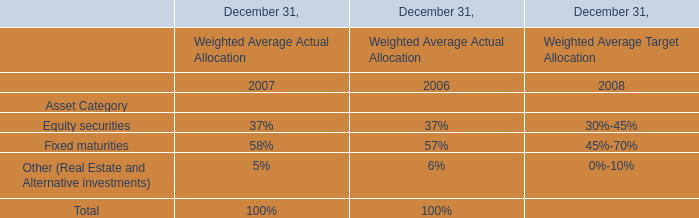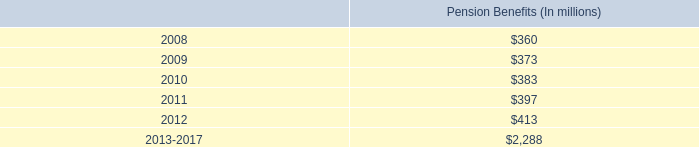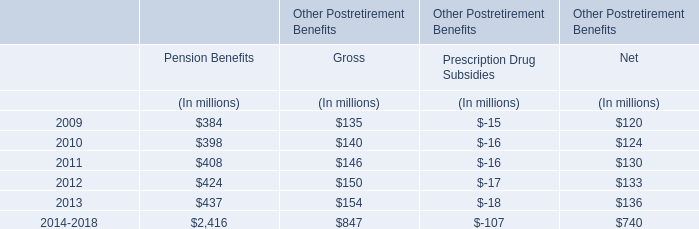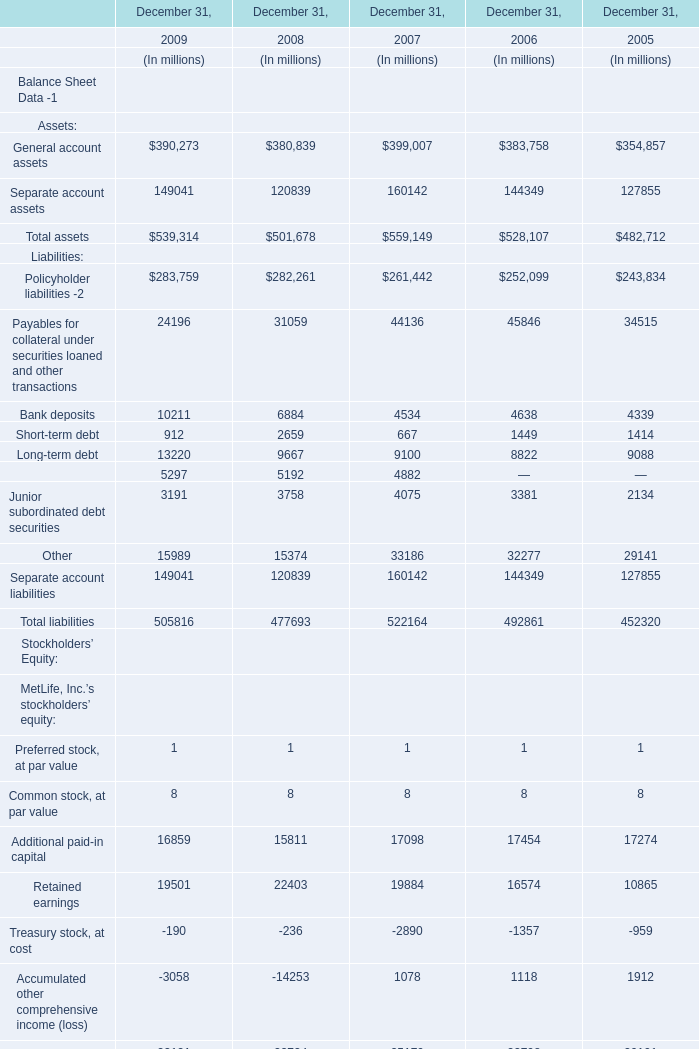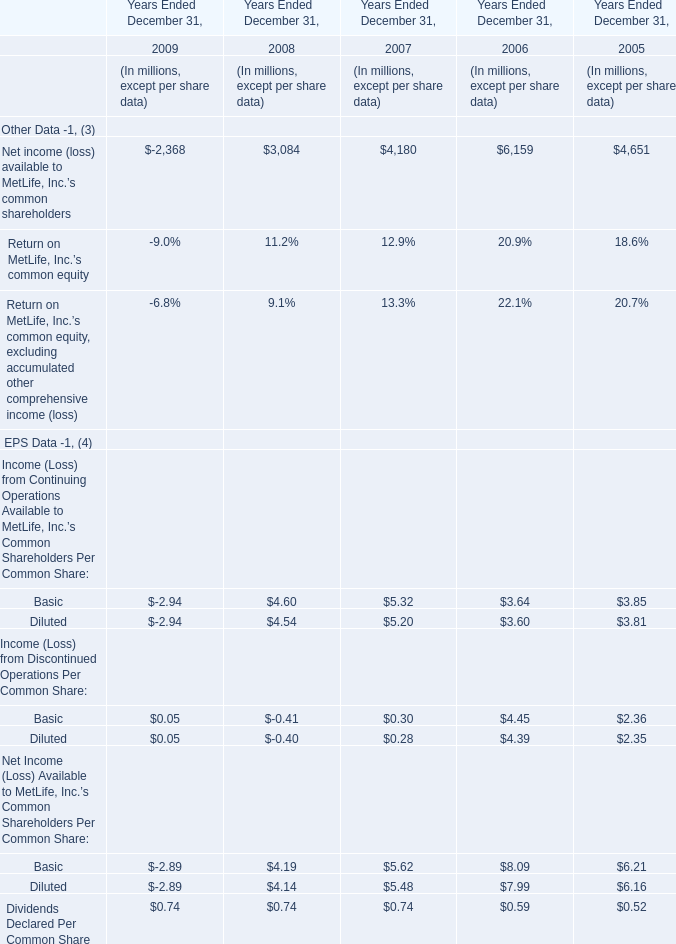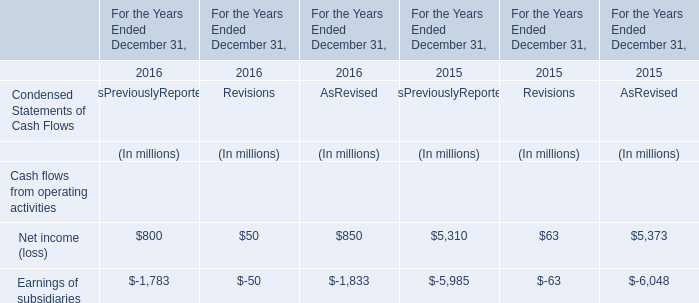In the year with the most Net income (loss) available to MetLife, Inc.'s common shareholders, what is the growth rate of Dividends Declared Per Common Share? 
Computations: ((0.59 - 0.52) / 0.52)
Answer: 0.13462. 